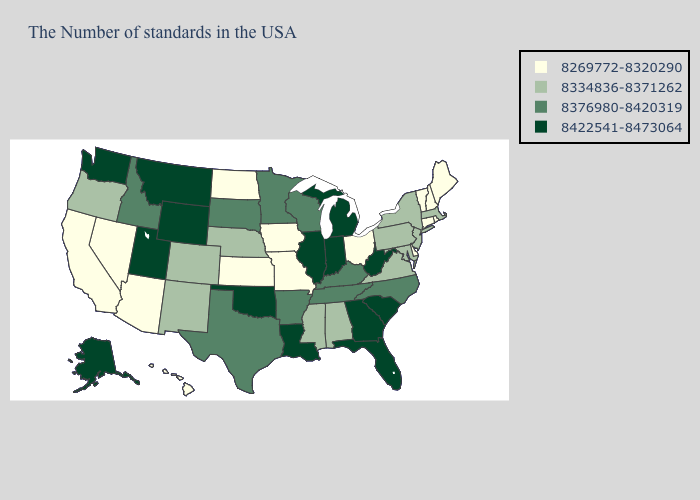What is the lowest value in the USA?
Keep it brief. 8269772-8320290. Does North Dakota have the highest value in the USA?
Write a very short answer. No. What is the value of Missouri?
Concise answer only. 8269772-8320290. What is the lowest value in states that border Pennsylvania?
Keep it brief. 8269772-8320290. Does South Dakota have the same value as Minnesota?
Keep it brief. Yes. What is the highest value in the USA?
Short answer required. 8422541-8473064. What is the value of West Virginia?
Be succinct. 8422541-8473064. Does Wisconsin have a higher value than West Virginia?
Concise answer only. No. What is the highest value in states that border California?
Answer briefly. 8334836-8371262. Does Georgia have the highest value in the USA?
Keep it brief. Yes. What is the value of Maryland?
Short answer required. 8334836-8371262. Among the states that border Montana , which have the lowest value?
Answer briefly. North Dakota. Does Texas have the highest value in the USA?
Quick response, please. No. Does Kentucky have the lowest value in the South?
Quick response, please. No. 